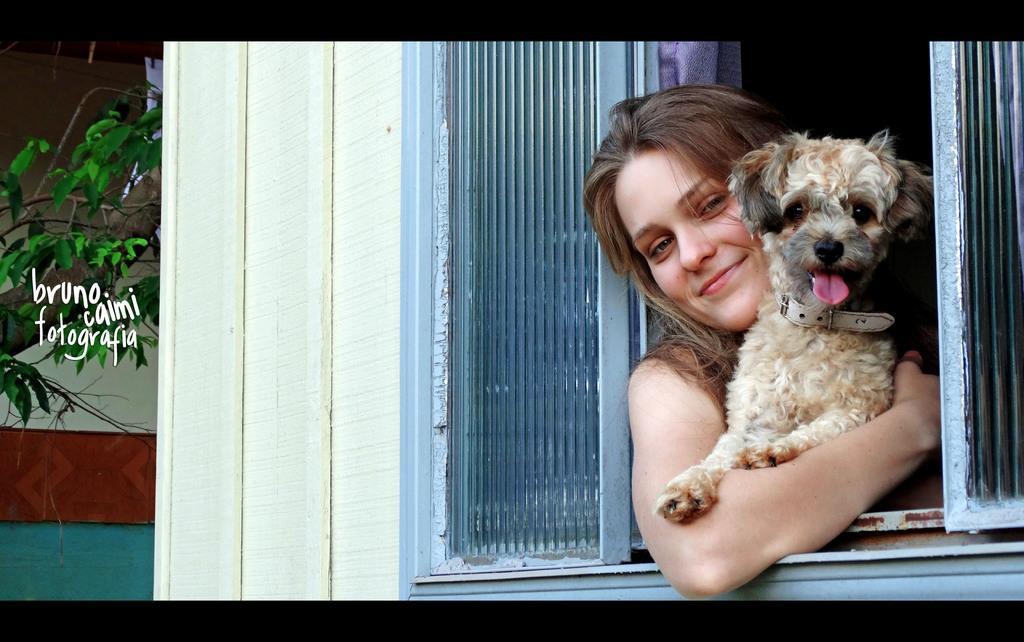Please provide a concise description of this image. In this picture we can see a lady holding a dog and they are out from a window and also a tree. 